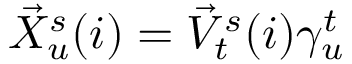Convert formula to latex. <formula><loc_0><loc_0><loc_500><loc_500>\begin{array} { r } { \vec { X } _ { u } ^ { s } ( i ) = \vec { V } _ { t } ^ { s } ( i ) \gamma _ { u } ^ { t } } \end{array}</formula> 